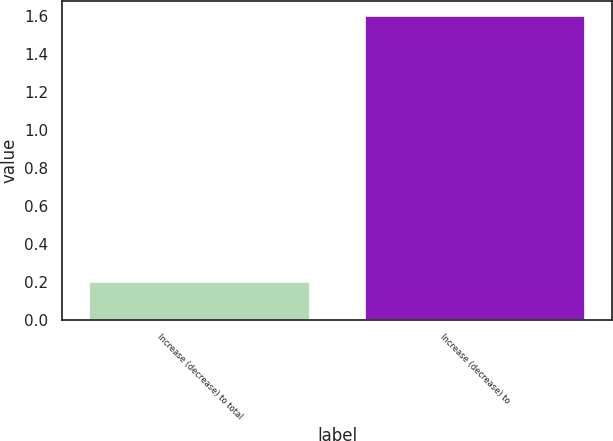Convert chart. <chart><loc_0><loc_0><loc_500><loc_500><bar_chart><fcel>Increase (decrease) to total<fcel>Increase (decrease) to<nl><fcel>0.2<fcel>1.6<nl></chart> 